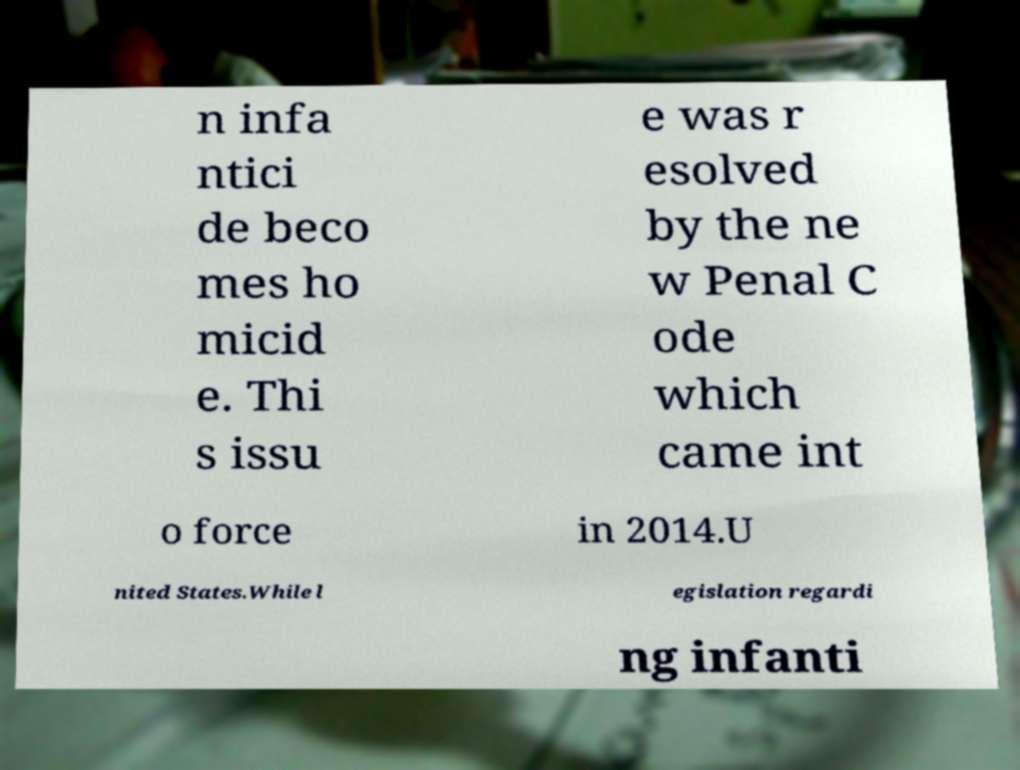Please read and relay the text visible in this image. What does it say? n infa ntici de beco mes ho micid e. Thi s issu e was r esolved by the ne w Penal C ode which came int o force in 2014.U nited States.While l egislation regardi ng infanti 